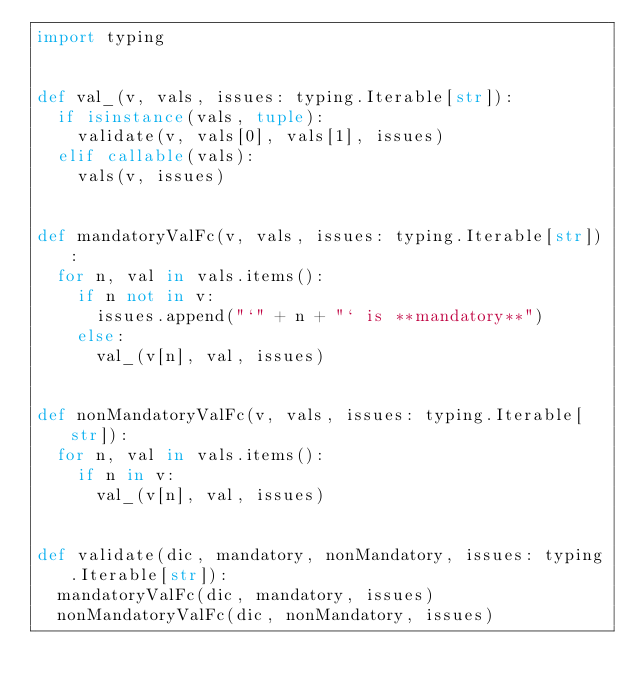<code> <loc_0><loc_0><loc_500><loc_500><_Python_>import typing


def val_(v, vals, issues: typing.Iterable[str]):
	if isinstance(vals, tuple):
		validate(v, vals[0], vals[1], issues)
	elif callable(vals):
		vals(v, issues)


def mandatoryValFc(v, vals, issues: typing.Iterable[str]):
	for n, val in vals.items():
		if n not in v:
			issues.append("`" + n + "` is **mandatory**")
		else:
			val_(v[n], val, issues)


def nonMandatoryValFc(v, vals, issues: typing.Iterable[str]):
	for n, val in vals.items():
		if n in v:
			val_(v[n], val, issues)


def validate(dic, mandatory, nonMandatory, issues: typing.Iterable[str]):
	mandatoryValFc(dic, mandatory, issues)
	nonMandatoryValFc(dic, nonMandatory, issues)
</code> 